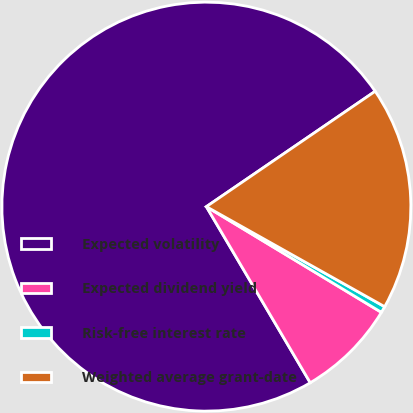Convert chart to OTSL. <chart><loc_0><loc_0><loc_500><loc_500><pie_chart><fcel>Expected volatility<fcel>Expected dividend yield<fcel>Risk-free interest rate<fcel>Weighted average grant-date<nl><fcel>73.94%<fcel>7.87%<fcel>0.51%<fcel>17.68%<nl></chart> 